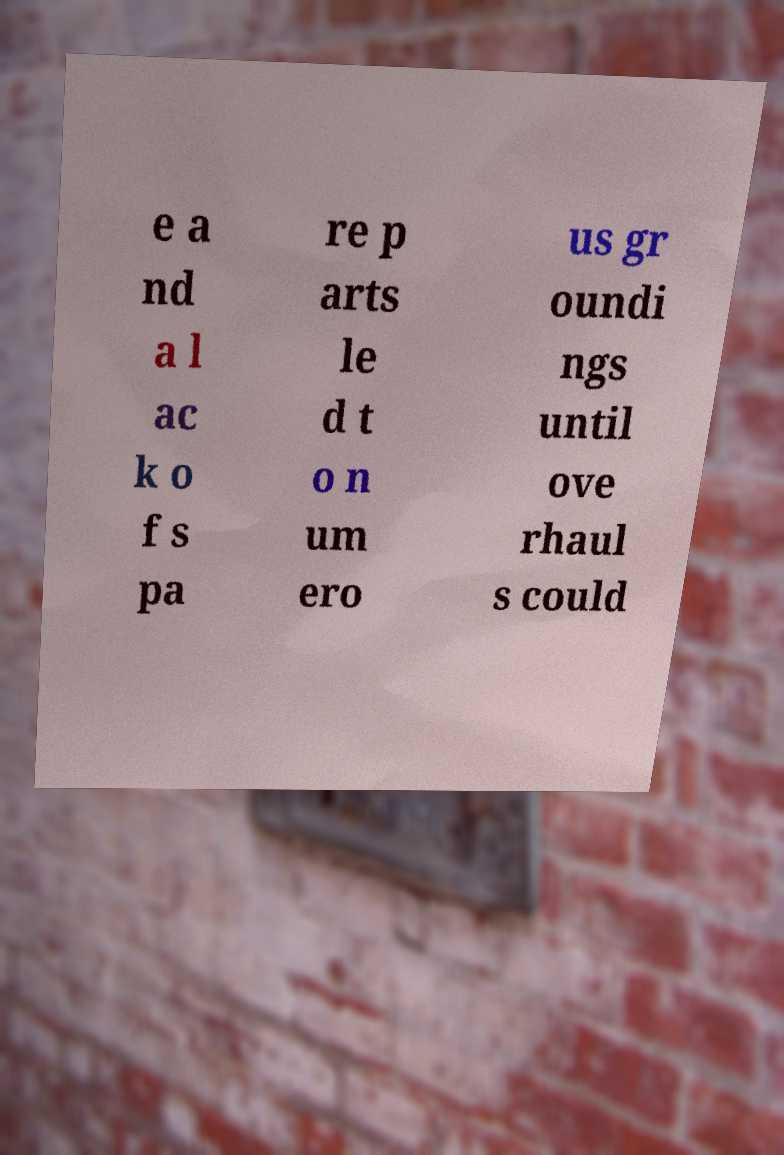Please read and relay the text visible in this image. What does it say? e a nd a l ac k o f s pa re p arts le d t o n um ero us gr oundi ngs until ove rhaul s could 